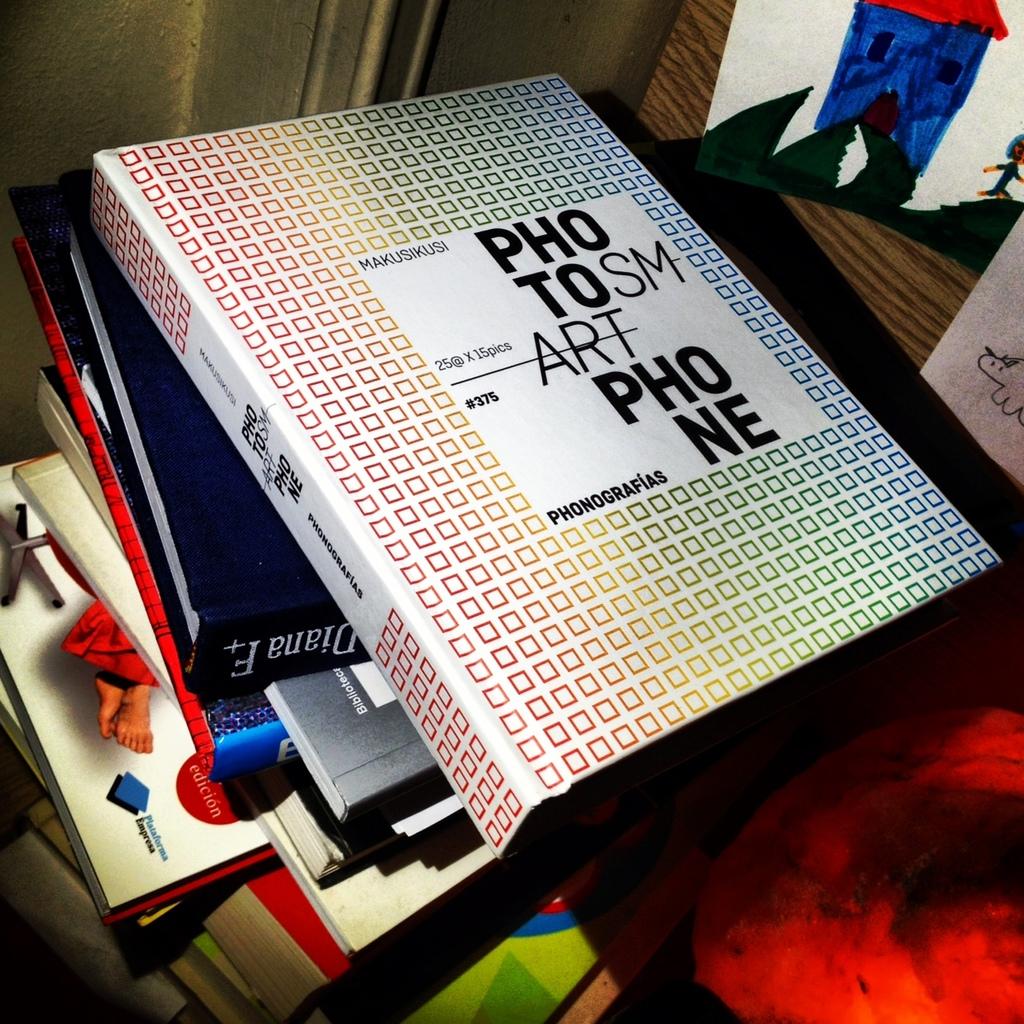What is the first book called?
Make the answer very short. Photo smart phone. 